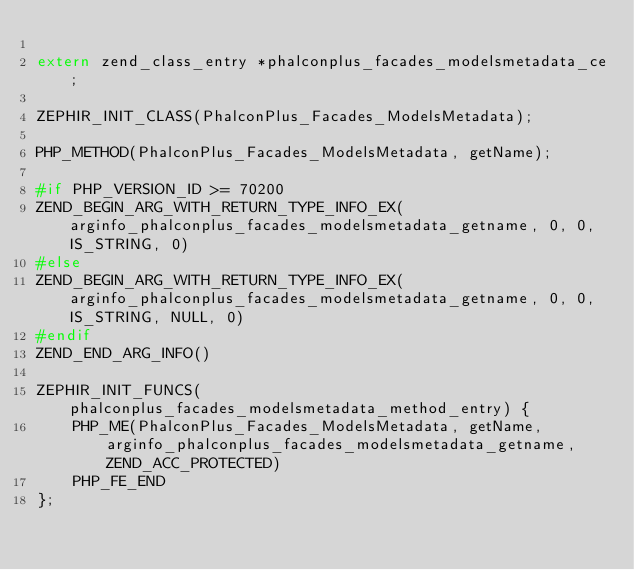Convert code to text. <code><loc_0><loc_0><loc_500><loc_500><_C_>
extern zend_class_entry *phalconplus_facades_modelsmetadata_ce;

ZEPHIR_INIT_CLASS(PhalconPlus_Facades_ModelsMetadata);

PHP_METHOD(PhalconPlus_Facades_ModelsMetadata, getName);

#if PHP_VERSION_ID >= 70200
ZEND_BEGIN_ARG_WITH_RETURN_TYPE_INFO_EX(arginfo_phalconplus_facades_modelsmetadata_getname, 0, 0, IS_STRING, 0)
#else
ZEND_BEGIN_ARG_WITH_RETURN_TYPE_INFO_EX(arginfo_phalconplus_facades_modelsmetadata_getname, 0, 0, IS_STRING, NULL, 0)
#endif
ZEND_END_ARG_INFO()

ZEPHIR_INIT_FUNCS(phalconplus_facades_modelsmetadata_method_entry) {
	PHP_ME(PhalconPlus_Facades_ModelsMetadata, getName, arginfo_phalconplus_facades_modelsmetadata_getname, ZEND_ACC_PROTECTED)
	PHP_FE_END
};
</code> 